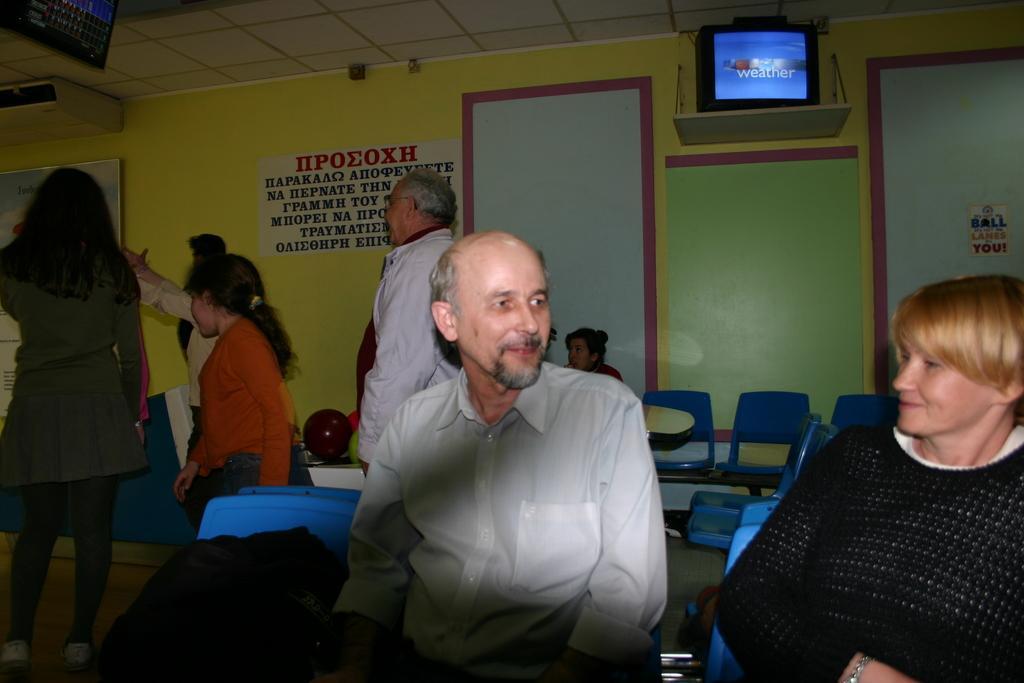Describe this image in one or two sentences. In the foreground of this image, there are persons sitting on the blue chairs and a bag on the chair. In the background, there are persons sitting, few are standing, wall, TV on the top, few boards, posters are on the wall. We can also see balls and a screen to the ceiling. 